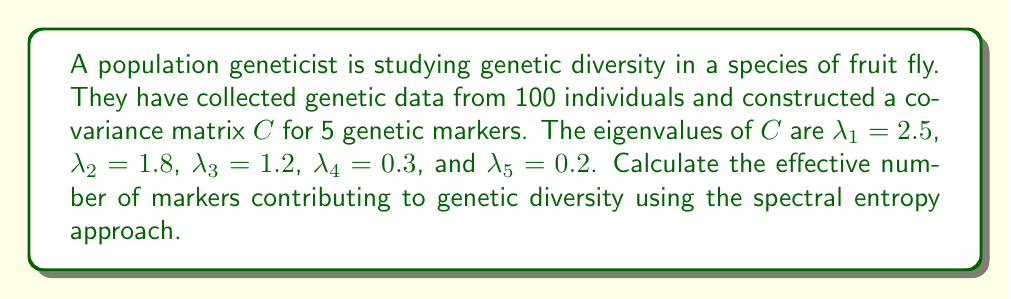Provide a solution to this math problem. To estimate genetic diversity using spectral decomposition, we'll follow these steps:

1) First, we need to calculate the total variance:
   $$\text{Total Variance} = \sum_{i=1}^{5} \lambda_i = 2.5 + 1.8 + 1.2 + 0.3 + 0.2 = 6$$

2) Next, we calculate the proportion of variance explained by each eigenvalue:
   $$p_i = \frac{\lambda_i}{\text{Total Variance}}$$
   
   $p_1 = 2.5/6 = 0.4167$
   $p_2 = 1.8/6 = 0.3000$
   $p_3 = 1.2/6 = 0.2000$
   $p_4 = 0.3/6 = 0.0500$
   $p_5 = 0.2/6 = 0.0333$

3) Now, we calculate the spectral entropy:
   $$H = -\sum_{i=1}^{5} p_i \ln(p_i)$$
   
   $H = -[0.4167 \ln(0.4167) + 0.3000 \ln(0.3000) + 0.2000 \ln(0.2000) + 0.0500 \ln(0.0500) + 0.0333 \ln(0.0333)]$
   
   $H = 1.3598$

4) Finally, we calculate the effective number of markers:
   $$N_{\text{eff}} = e^H = e^{1.3598} = 3.8955$$

The effective number of markers represents the equivalent number of independent markers that would produce the same level of genetic diversity.
Answer: 3.90 markers 